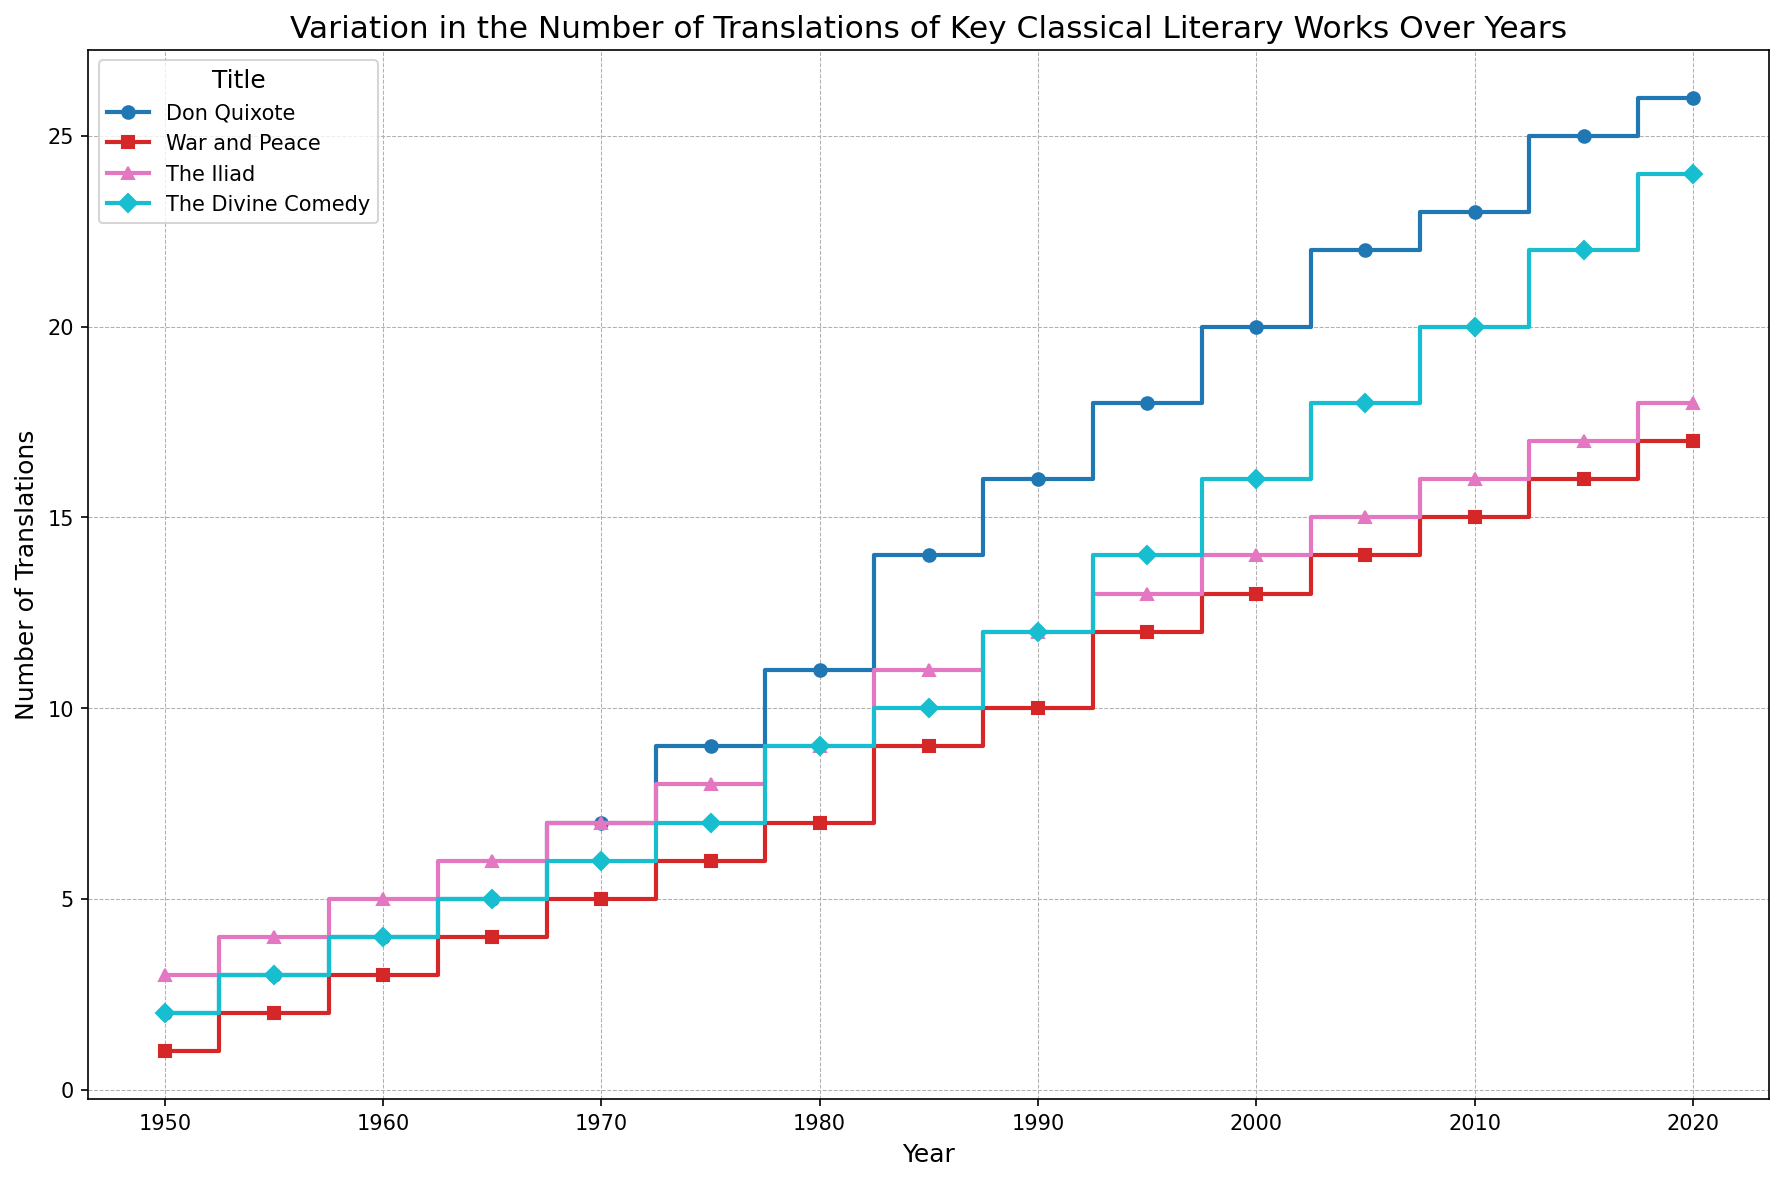Which title had the highest number of translations in 2020? In the year 2020, look at the ending value for each title's step line. The Divine Comedy ends at 24, which is higher than the other titles.
Answer: The Divine Comedy Between 1950 and 1960, which title had the steepest increase in translations? Compare the increase in the number of translations for each title from 1950 to 1960. Don Quixote increased from 2 to 4 (+2), War and Peace from 1 to 3 (+2), The Iliad from 3 to 5 (+2), and The Divine Comedy from 2 to 4 (+2). They all had the same steepness.
Answer: All titles had the same steepness What is the difference in the number of translations of Don Quixote and The Iliad in 1985? In 1985, Don Quixote has 14 translations, and The Iliad has 11. Subtract the lower value from the higher value: 14 - 11 = 3.
Answer: 3 Which title had the smallest number of translations in 2000? In the year 2000, compare the translations of each title. Don Quixote has 20, War and Peace has 13, The Iliad has 14, and The Divine Comedy has 16. War and Peace has the smallest number.
Answer: War and Peace By how much did the number of translations of The Divine Comedy increase between 1950 and 2020? Compare the number of translations in 1950 and 2020 for The Divine Comedy: 24 - 2 = 22.
Answer: 22 Between 2000 and 2010, which title had the least increase in translations? Compare the increase for each title from 2000 to 2010: Don Quixote increased by 3, War and Peace by 2, The Iliad by 2, and The Divine Comedy by 4. War and Peace and The Iliad had the least increase.
Answer: War and Peace and The Iliad Which title had more translations than The Iliad in 1965? In 1965, compare the translations: The Iliad has 6, Don Quixote has 5, War and Peace has 4, and The Divine Comedy has 5. The Iliad had the most translations in 1965.
Answer: None What is the total number of translations for all titles combined in 1980? Sum the number of translations in 1980: Don Quixote (11) + War and Peace (7) + The Iliad (9) + The Divine Comedy (9) = 36.
Answer: 36 Which title showed a consistent increase in translations every period (every 5 years) from 1950 to 2020? Check for a consistent rise every 5 years: Don Quixote, War and Peace, The Iliad, and The Divine Comedy. All titles show a consistent increase.
Answer: All titles 